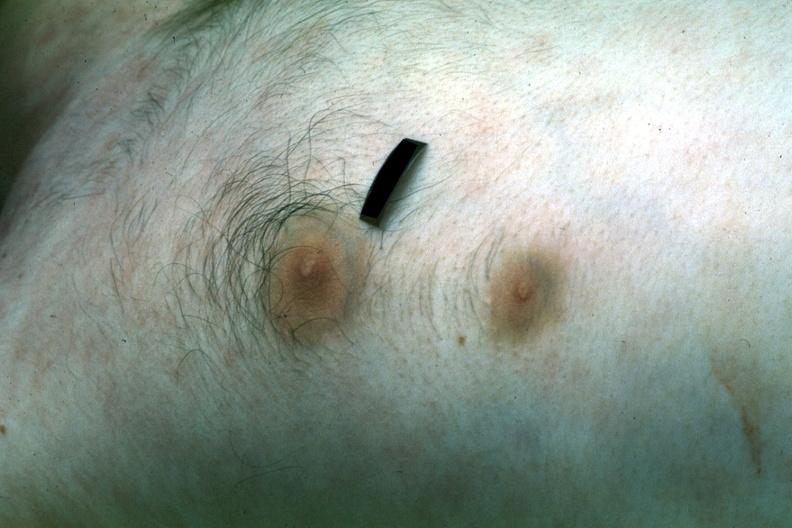s breast present?
Answer the question using a single word or phrase. Yes 